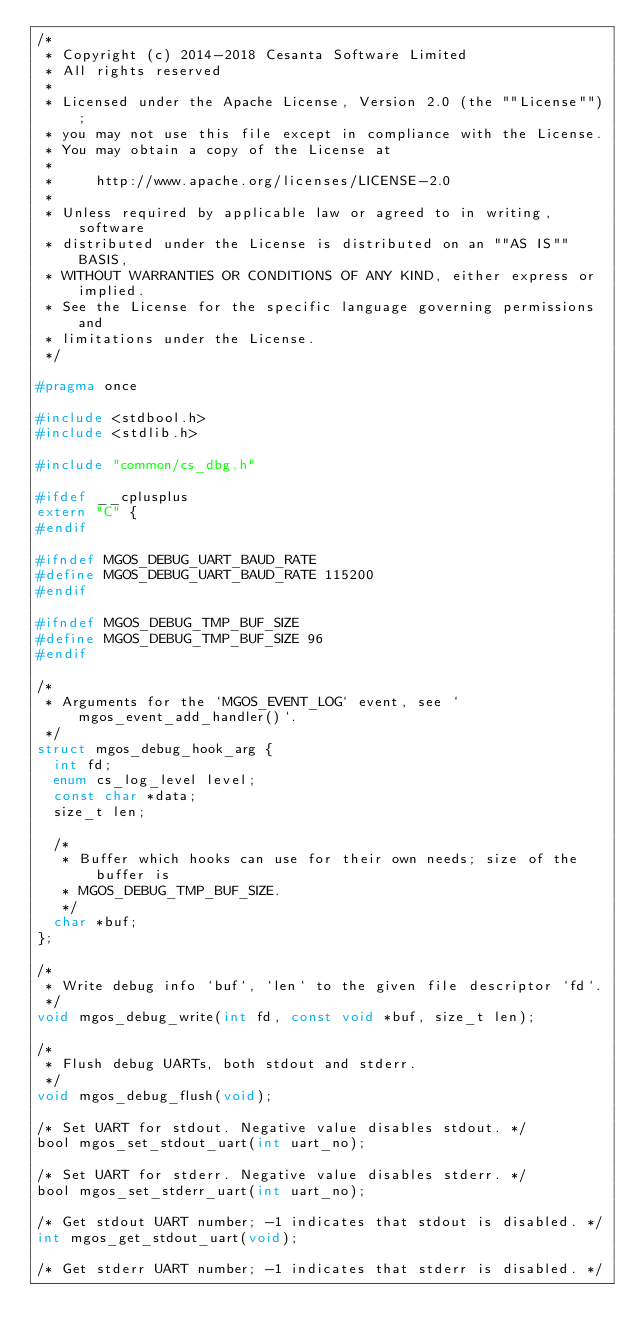Convert code to text. <code><loc_0><loc_0><loc_500><loc_500><_C_>/*
 * Copyright (c) 2014-2018 Cesanta Software Limited
 * All rights reserved
 *
 * Licensed under the Apache License, Version 2.0 (the ""License"");
 * you may not use this file except in compliance with the License.
 * You may obtain a copy of the License at
 *
 *     http://www.apache.org/licenses/LICENSE-2.0
 *
 * Unless required by applicable law or agreed to in writing, software
 * distributed under the License is distributed on an ""AS IS"" BASIS,
 * WITHOUT WARRANTIES OR CONDITIONS OF ANY KIND, either express or implied.
 * See the License for the specific language governing permissions and
 * limitations under the License.
 */

#pragma once

#include <stdbool.h>
#include <stdlib.h>

#include "common/cs_dbg.h"

#ifdef __cplusplus
extern "C" {
#endif

#ifndef MGOS_DEBUG_UART_BAUD_RATE
#define MGOS_DEBUG_UART_BAUD_RATE 115200
#endif

#ifndef MGOS_DEBUG_TMP_BUF_SIZE
#define MGOS_DEBUG_TMP_BUF_SIZE 96
#endif

/*
 * Arguments for the `MGOS_EVENT_LOG` event, see `mgos_event_add_handler()`.
 */
struct mgos_debug_hook_arg {
  int fd;
  enum cs_log_level level;
  const char *data;
  size_t len;

  /*
   * Buffer which hooks can use for their own needs; size of the buffer is
   * MGOS_DEBUG_TMP_BUF_SIZE.
   */
  char *buf;
};

/*
 * Write debug info `buf`, `len` to the given file descriptor `fd`.
 */
void mgos_debug_write(int fd, const void *buf, size_t len);

/*
 * Flush debug UARTs, both stdout and stderr.
 */
void mgos_debug_flush(void);

/* Set UART for stdout. Negative value disables stdout. */
bool mgos_set_stdout_uart(int uart_no);

/* Set UART for stderr. Negative value disables stderr. */
bool mgos_set_stderr_uart(int uart_no);

/* Get stdout UART number; -1 indicates that stdout is disabled. */
int mgos_get_stdout_uart(void);

/* Get stderr UART number; -1 indicates that stderr is disabled. */</code> 